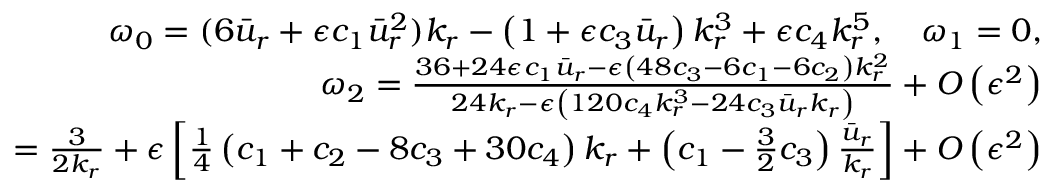Convert formula to latex. <formula><loc_0><loc_0><loc_500><loc_500>\begin{array} { r l r } & { \omega _ { 0 } = ( 6 \bar { u } _ { r } + \epsilon c _ { 1 } \bar { u } _ { r } ^ { 2 } ) k _ { r } - \left ( 1 + \epsilon c _ { 3 } \bar { u } _ { r } \right ) k _ { r } ^ { 3 } + \epsilon c _ { 4 } k _ { r } ^ { 5 } , \quad \omega _ { 1 } = 0 , } \\ & { \omega _ { 2 } = \frac { 3 6 + 2 4 \epsilon c _ { 1 } \bar { u } _ { r } - \epsilon \left ( 4 8 c _ { 3 } - 6 c _ { 1 } - 6 c _ { 2 } \right ) k _ { r } ^ { 2 } } { 2 4 k _ { r } - \epsilon \left ( 1 2 0 c _ { 4 } k _ { r } ^ { 3 } - 2 4 c _ { 3 } \bar { u } _ { r } k _ { r } \right ) } + O \left ( \epsilon ^ { 2 } \right ) } \\ & { = \frac { 3 } { 2 k _ { r } } + \epsilon \left [ \frac { 1 } { 4 } \left ( c _ { 1 } + c _ { 2 } - 8 c _ { 3 } + 3 0 c _ { 4 } \right ) k _ { r } + \left ( c _ { 1 } - \frac { 3 } { 2 } c _ { 3 } \right ) \frac { \bar { u } _ { r } } { k _ { r } } \right ] + O \left ( \epsilon ^ { 2 } \right ) } \end{array}</formula> 